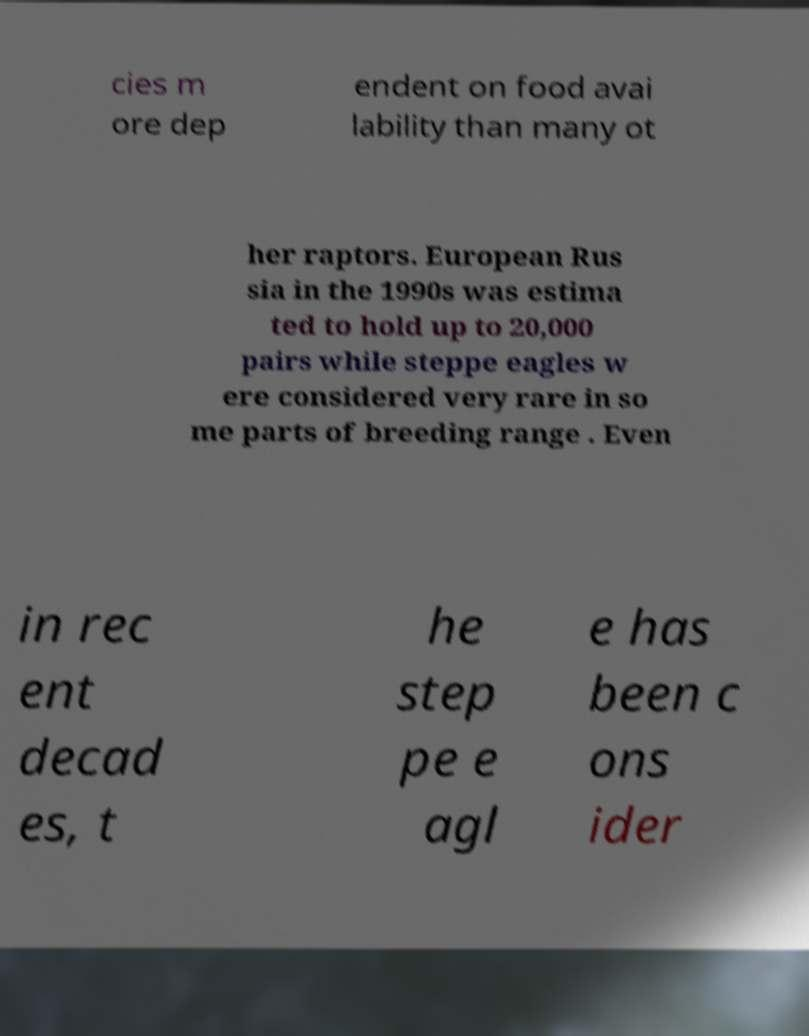Please identify and transcribe the text found in this image. cies m ore dep endent on food avai lability than many ot her raptors. European Rus sia in the 1990s was estima ted to hold up to 20,000 pairs while steppe eagles w ere considered very rare in so me parts of breeding range . Even in rec ent decad es, t he step pe e agl e has been c ons ider 